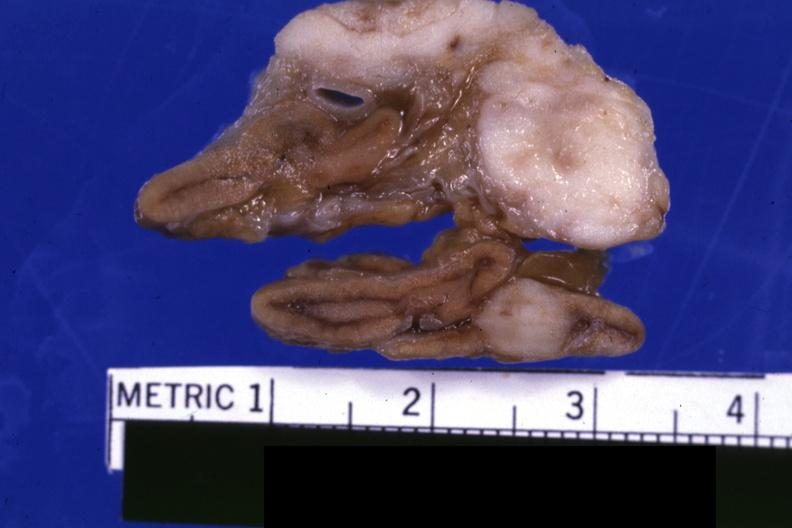s carcinoma metastatic lung present?
Answer the question using a single word or phrase. Yes 